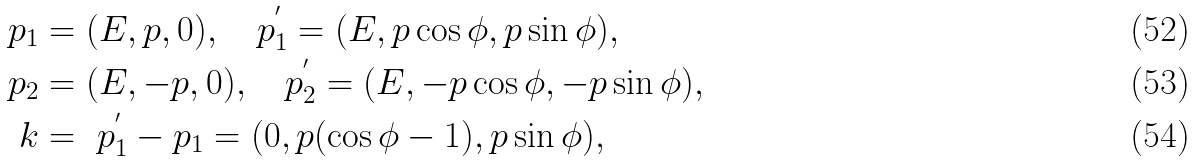Convert formula to latex. <formula><loc_0><loc_0><loc_500><loc_500>p _ { 1 } & = ( E , p , 0 ) , \text { \ \ } p _ { 1 } ^ { ^ { \prime } } = ( E , p \cos \phi , p \sin \phi ) , \\ p _ { 2 } & = ( E , - p , 0 ) , \text { \ \ } p _ { 2 } ^ { ^ { \prime } } = ( E , - p \cos \phi , - p \sin \phi ) , \\ k & = \text {\ } p _ { 1 } ^ { ^ { \prime } } - p _ { 1 } = ( 0 , p ( \cos \phi - 1 ) , p \sin \phi ) ,</formula> 